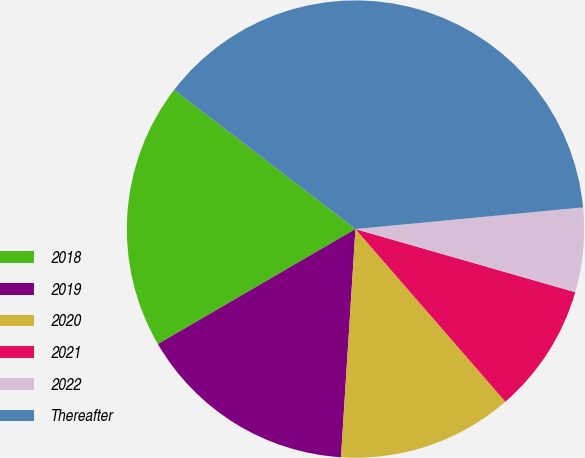Convert chart to OTSL. <chart><loc_0><loc_0><loc_500><loc_500><pie_chart><fcel>2018<fcel>2019<fcel>2020<fcel>2021<fcel>2022<fcel>Thereafter<nl><fcel>18.81%<fcel>15.6%<fcel>12.39%<fcel>9.17%<fcel>5.96%<fcel>38.07%<nl></chart> 